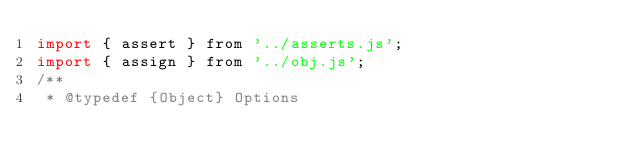<code> <loc_0><loc_0><loc_500><loc_500><_JavaScript_>import { assert } from '../asserts.js';
import { assign } from '../obj.js';
/**
 * @typedef {Object} Options</code> 